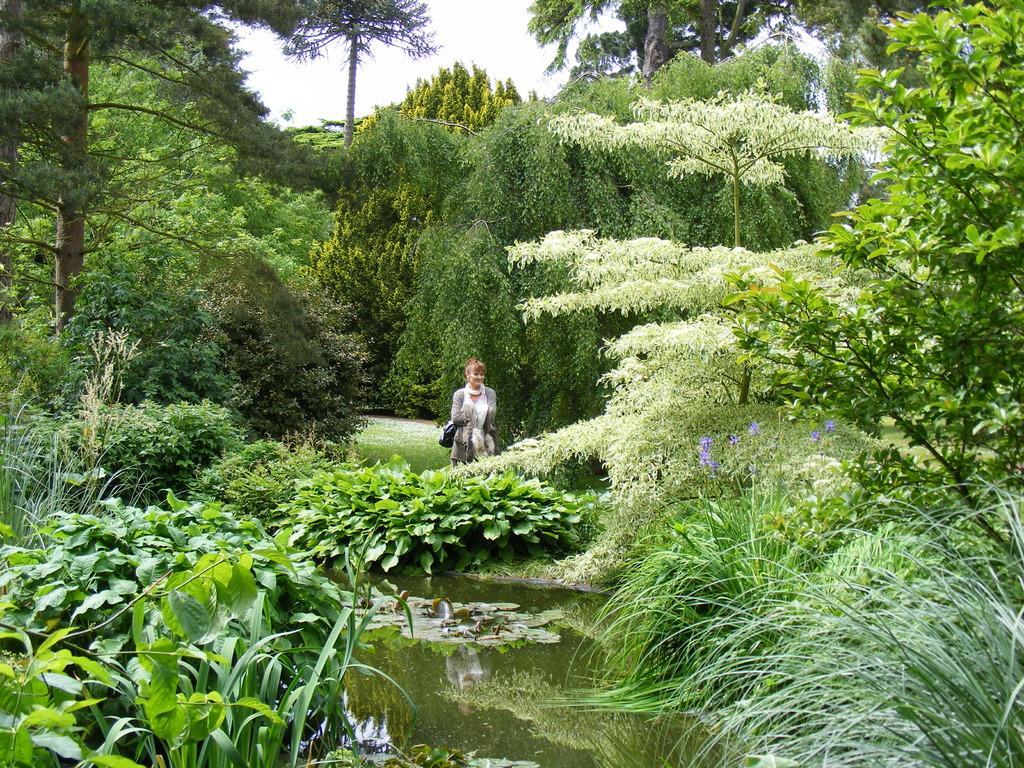Could you give a brief overview of what you see in this image? In the image there are plenty of trees and plants and in the middle there is a woman and in front of the woman there is a water surface. 